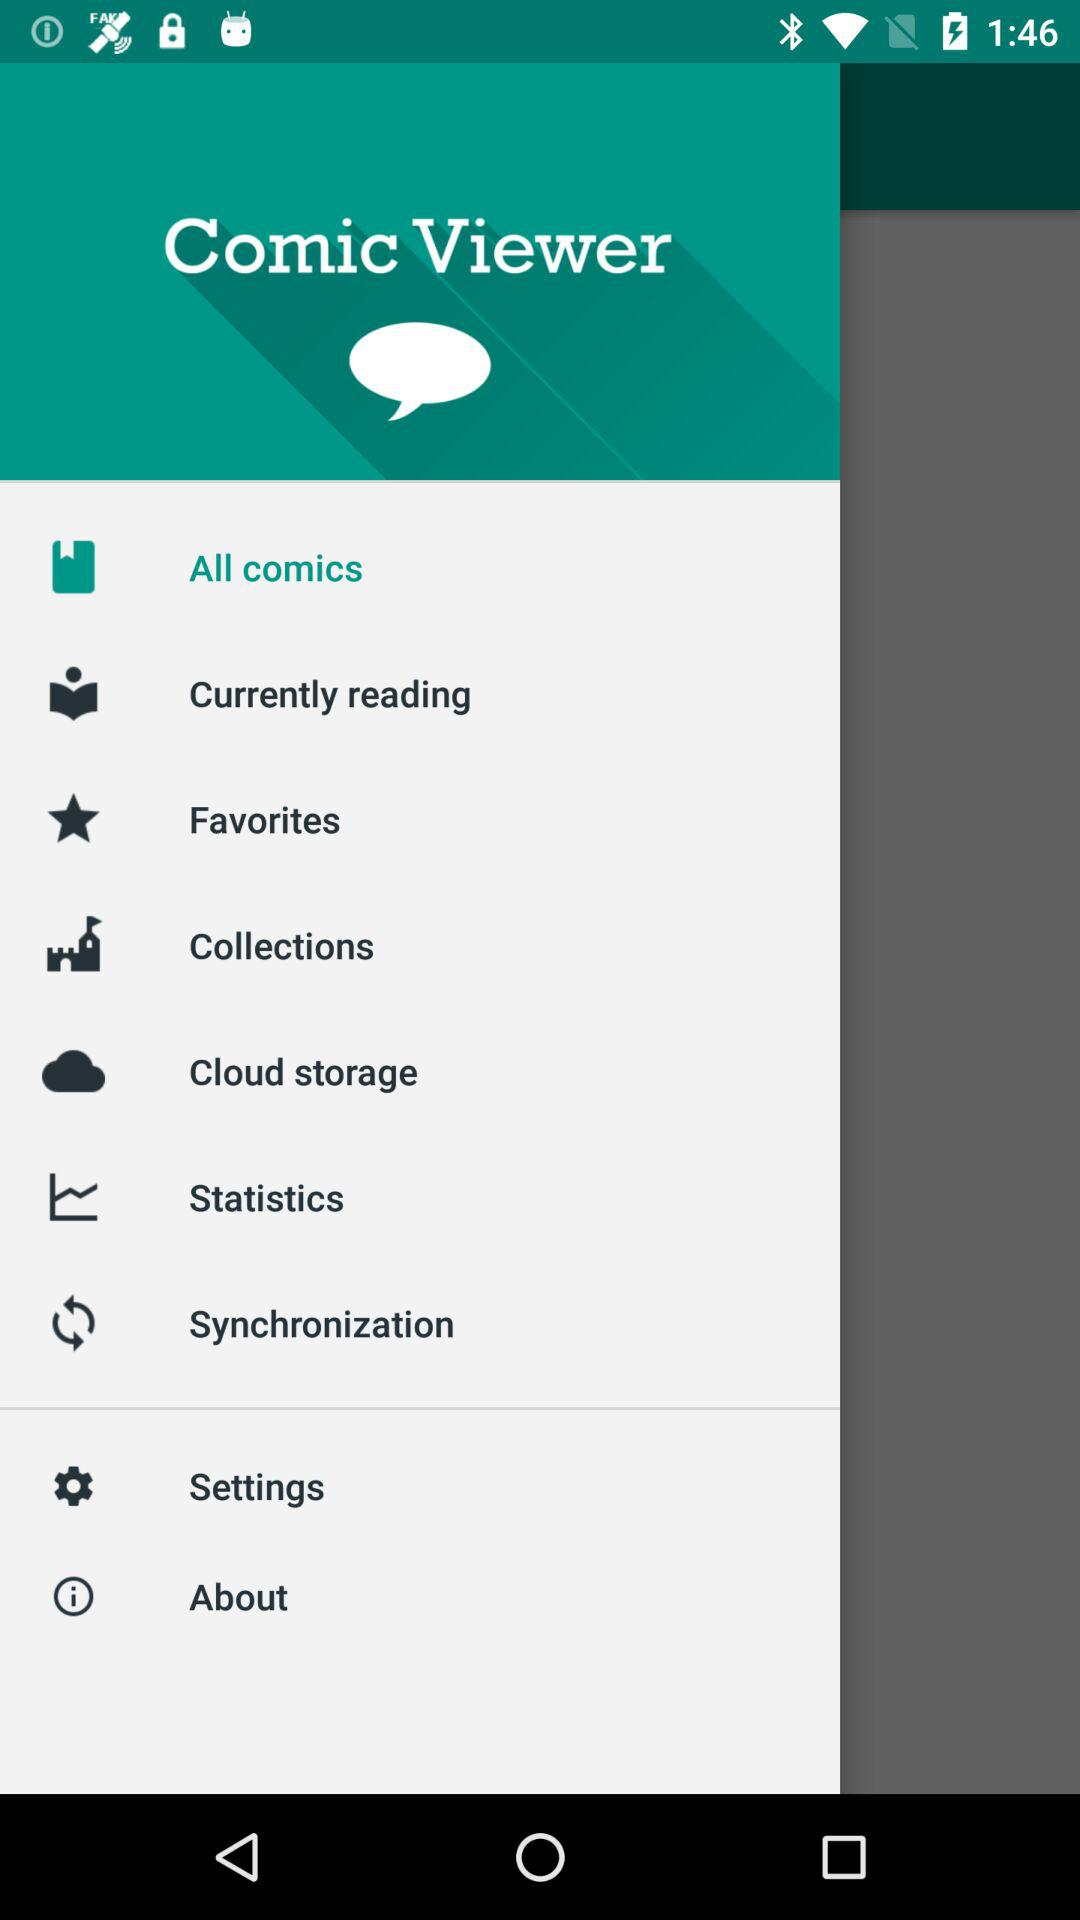What is the name of the application? The name of the application is "Comic Viewer". 